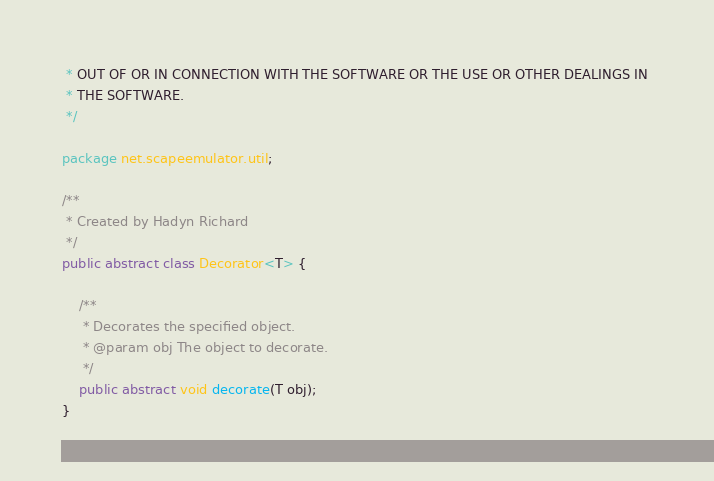Convert code to text. <code><loc_0><loc_0><loc_500><loc_500><_Java_> * OUT OF OR IN CONNECTION WITH THE SOFTWARE OR THE USE OR OTHER DEALINGS IN 
 * THE SOFTWARE.
 */

package net.scapeemulator.util;

/**
 * Created by Hadyn Richard
 */
public abstract class Decorator<T> {

    /**
     * Decorates the specified object.
     * @param obj The object to decorate.
     */
    public abstract void decorate(T obj);
}
</code> 